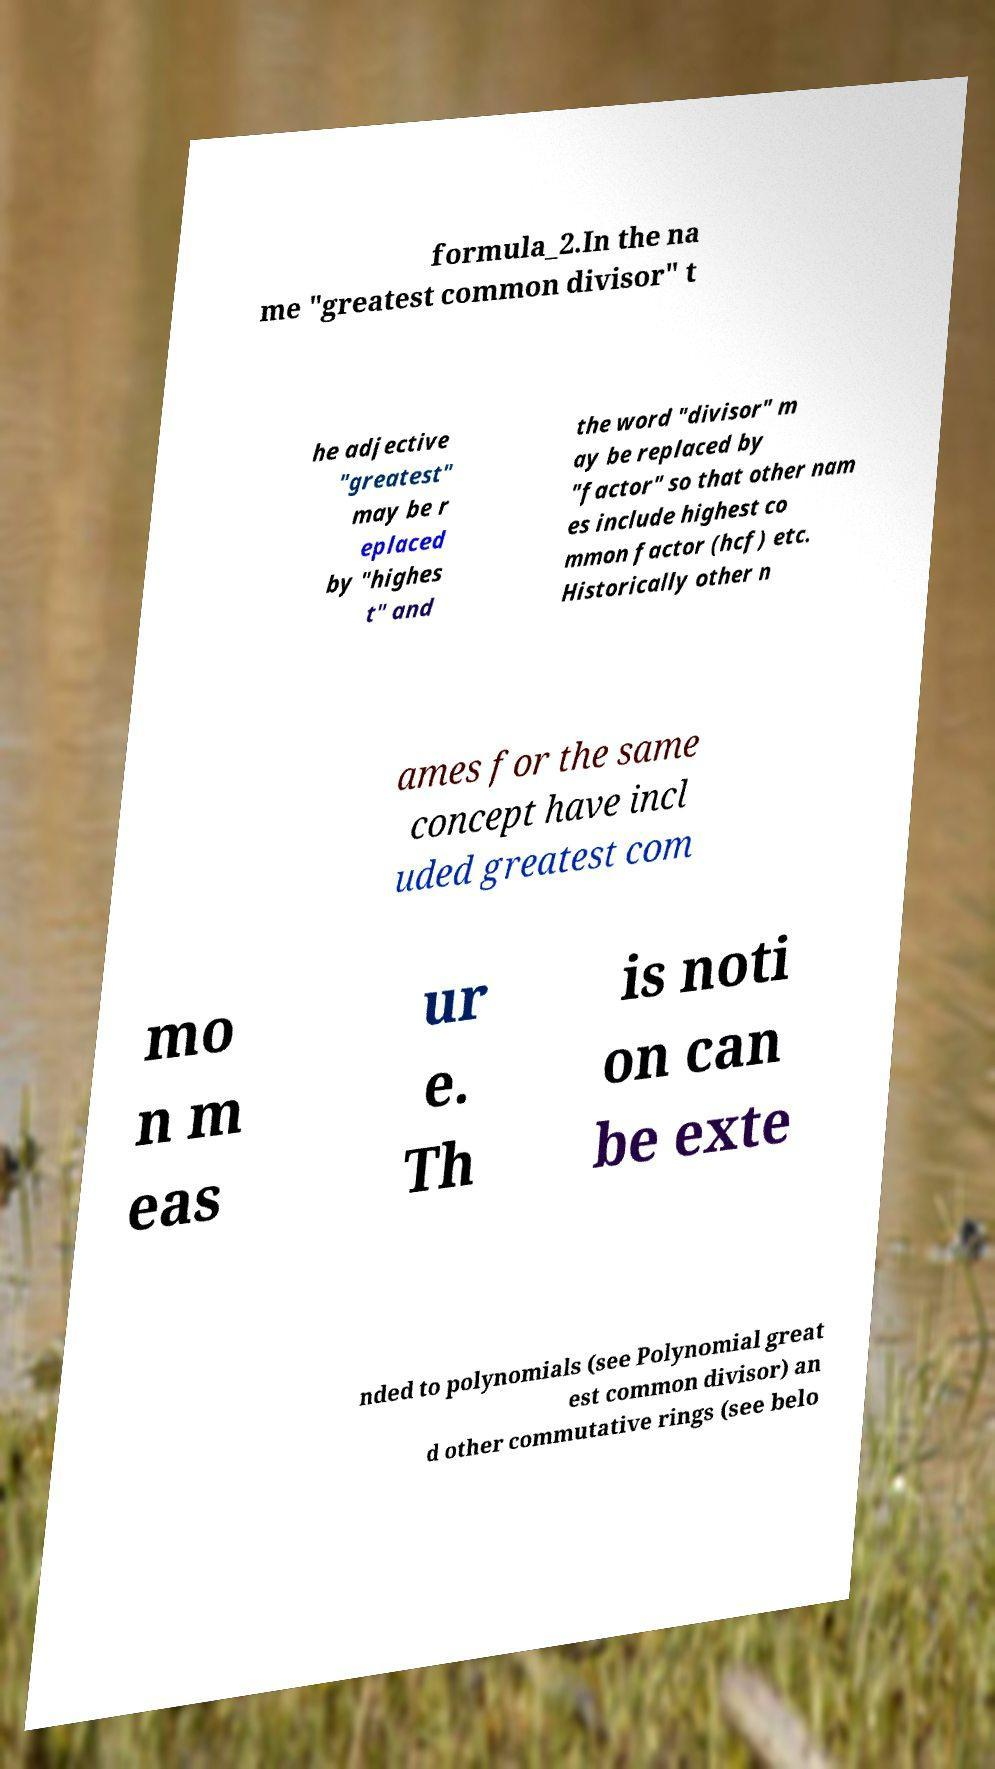Could you assist in decoding the text presented in this image and type it out clearly? formula_2.In the na me "greatest common divisor" t he adjective "greatest" may be r eplaced by "highes t" and the word "divisor" m ay be replaced by "factor" so that other nam es include highest co mmon factor (hcf) etc. Historically other n ames for the same concept have incl uded greatest com mo n m eas ur e. Th is noti on can be exte nded to polynomials (see Polynomial great est common divisor) an d other commutative rings (see belo 